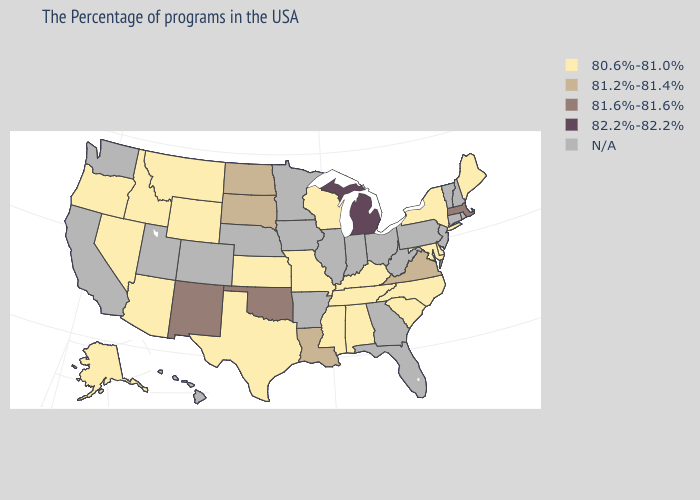Name the states that have a value in the range 81.6%-81.6%?
Short answer required. Massachusetts, Oklahoma, New Mexico. Name the states that have a value in the range N/A?
Quick response, please. Rhode Island, New Hampshire, Vermont, Connecticut, New Jersey, Pennsylvania, West Virginia, Ohio, Florida, Georgia, Indiana, Illinois, Arkansas, Minnesota, Iowa, Nebraska, Colorado, Utah, California, Washington, Hawaii. Does Oregon have the lowest value in the USA?
Give a very brief answer. Yes. What is the highest value in the USA?
Quick response, please. 82.2%-82.2%. Which states have the highest value in the USA?
Quick response, please. Michigan. Name the states that have a value in the range 81.2%-81.4%?
Short answer required. Virginia, Louisiana, South Dakota, North Dakota. What is the highest value in the MidWest ?
Write a very short answer. 82.2%-82.2%. Does Maryland have the lowest value in the USA?
Keep it brief. Yes. What is the lowest value in the Northeast?
Answer briefly. 80.6%-81.0%. Does Michigan have the highest value in the USA?
Write a very short answer. Yes. Which states hav the highest value in the MidWest?
Short answer required. Michigan. Among the states that border Massachusetts , which have the lowest value?
Answer briefly. New York. Name the states that have a value in the range 80.6%-81.0%?
Give a very brief answer. Maine, New York, Delaware, Maryland, North Carolina, South Carolina, Kentucky, Alabama, Tennessee, Wisconsin, Mississippi, Missouri, Kansas, Texas, Wyoming, Montana, Arizona, Idaho, Nevada, Oregon, Alaska. Which states have the lowest value in the West?
Concise answer only. Wyoming, Montana, Arizona, Idaho, Nevada, Oregon, Alaska. Which states have the highest value in the USA?
Give a very brief answer. Michigan. 